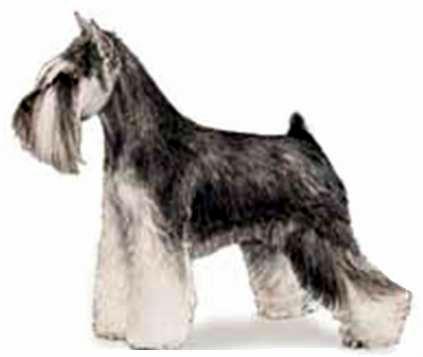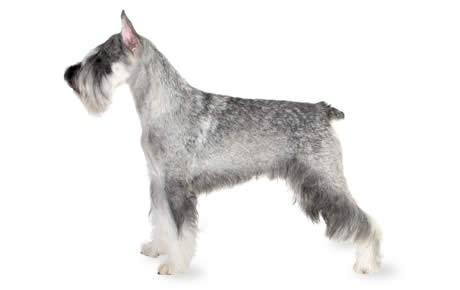The first image is the image on the left, the second image is the image on the right. Evaluate the accuracy of this statement regarding the images: "All dogs are facing to the left.". Is it true? Answer yes or no. Yes. 